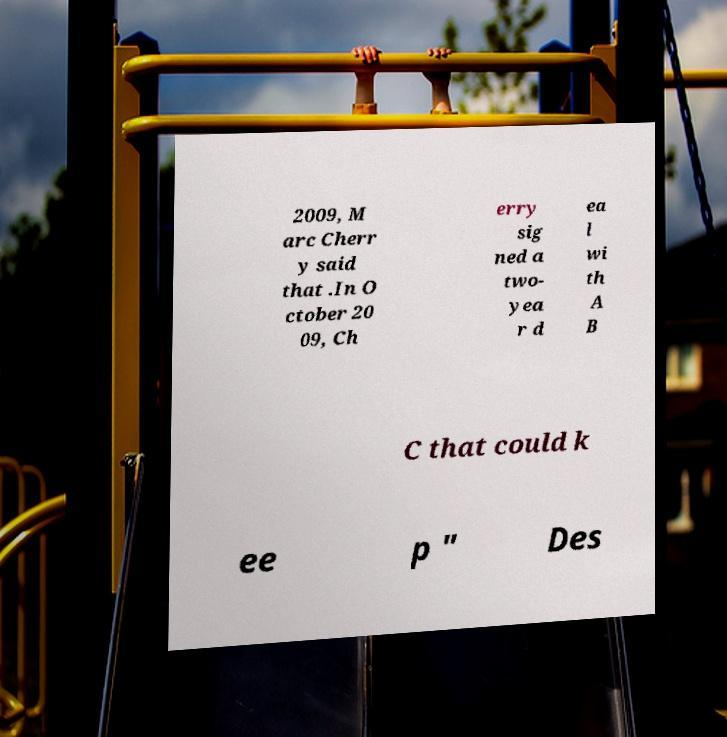What messages or text are displayed in this image? I need them in a readable, typed format. 2009, M arc Cherr y said that .In O ctober 20 09, Ch erry sig ned a two- yea r d ea l wi th A B C that could k ee p " Des 